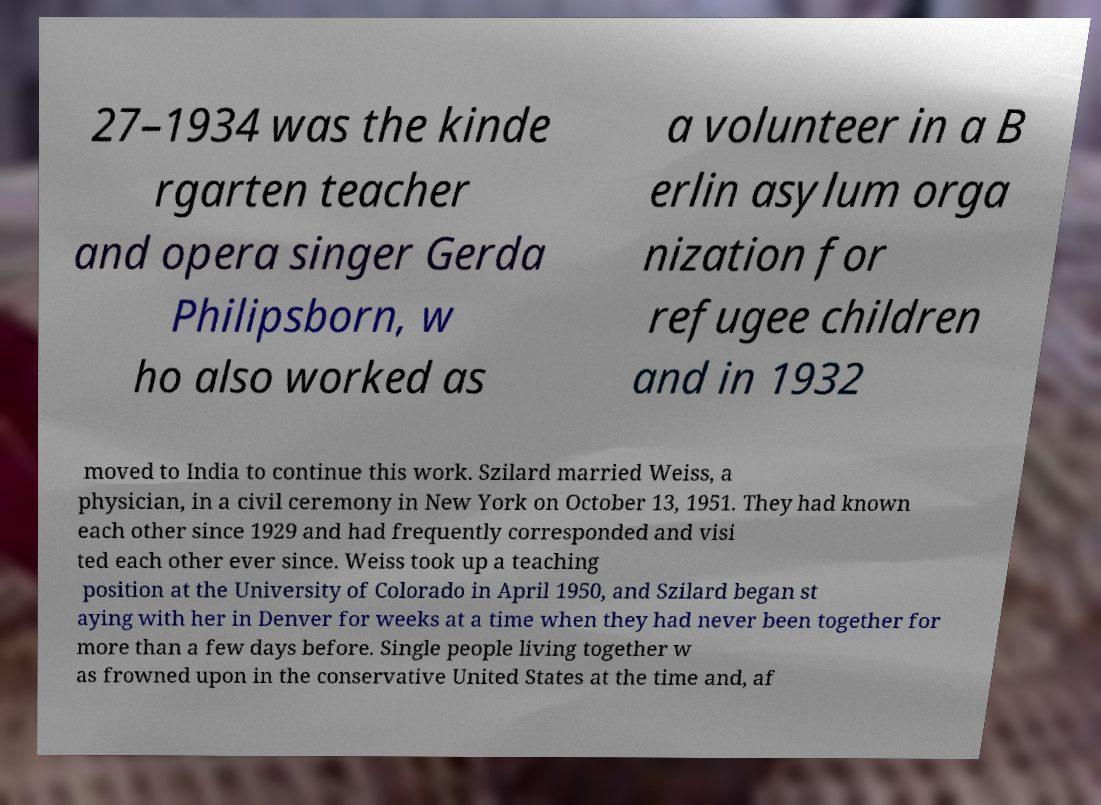Can you read and provide the text displayed in the image?This photo seems to have some interesting text. Can you extract and type it out for me? 27–1934 was the kinde rgarten teacher and opera singer Gerda Philipsborn, w ho also worked as a volunteer in a B erlin asylum orga nization for refugee children and in 1932 moved to India to continue this work. Szilard married Weiss, a physician, in a civil ceremony in New York on October 13, 1951. They had known each other since 1929 and had frequently corresponded and visi ted each other ever since. Weiss took up a teaching position at the University of Colorado in April 1950, and Szilard began st aying with her in Denver for weeks at a time when they had never been together for more than a few days before. Single people living together w as frowned upon in the conservative United States at the time and, af 